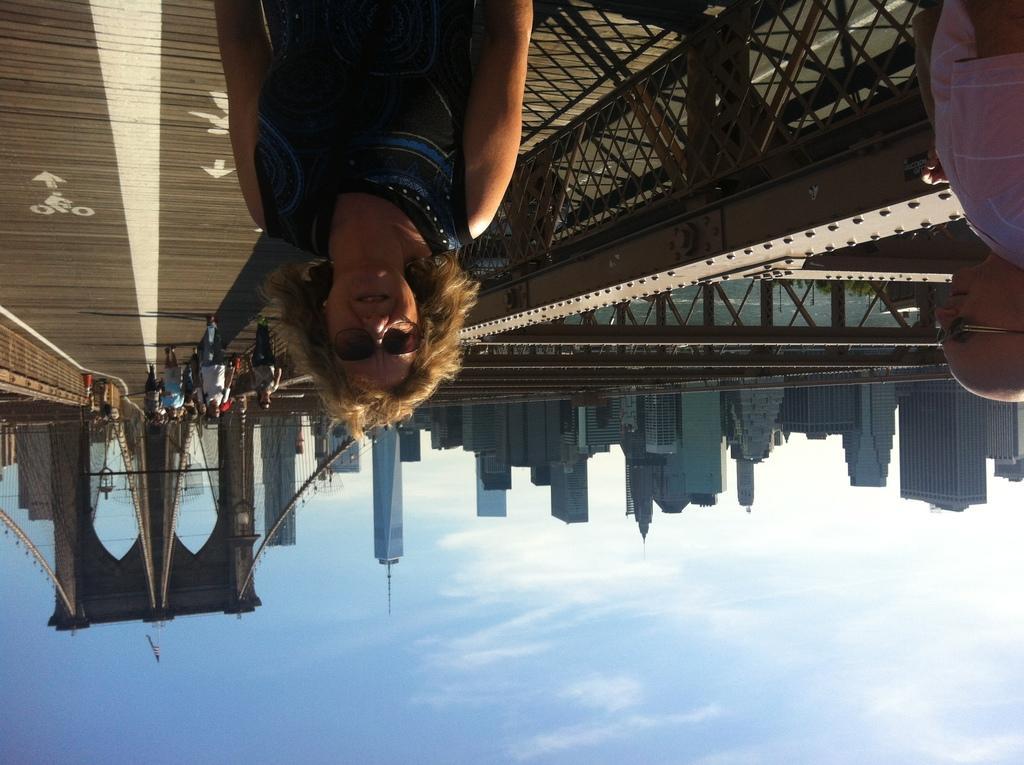Can you describe this image briefly? In this image we can see few people, buildings, arches, and road. Here we can see sky. 